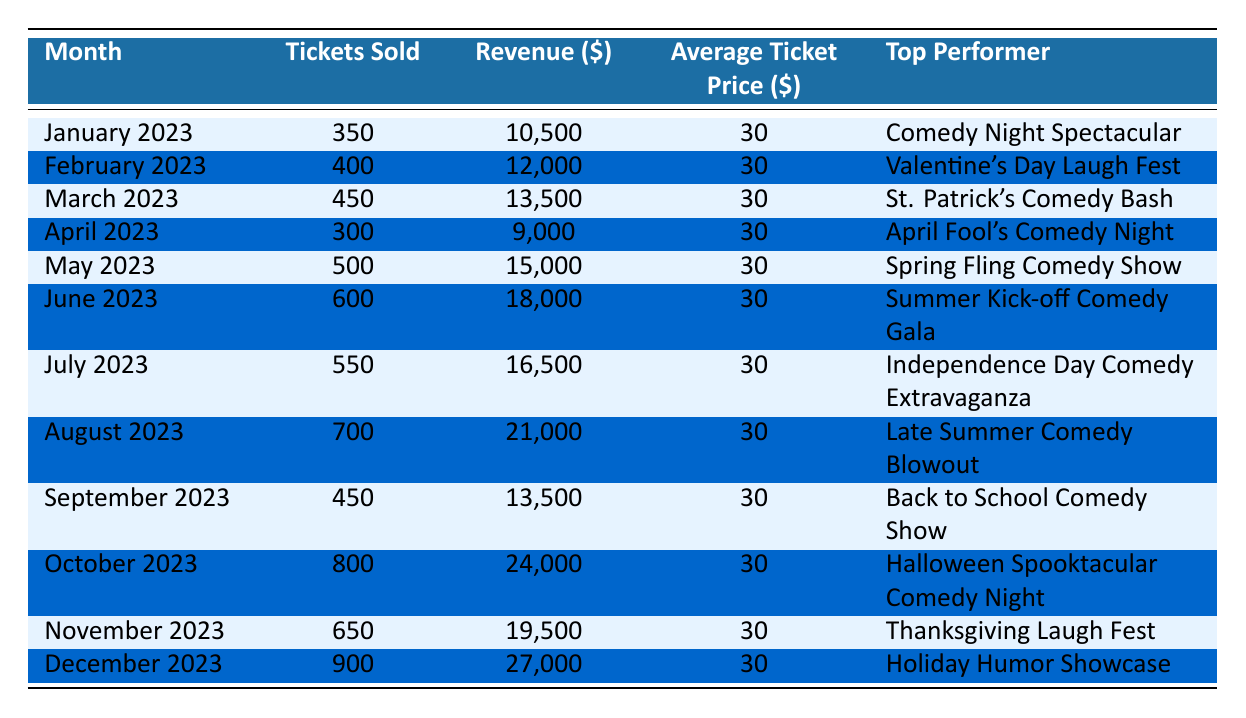What was the total revenue for the comedy club in August 2023? Looking at the table, the revenue listed for August 2023 is 21,000 dollars. This is a direct retrieval of information from the respective row.
Answer: 21,000 Which month had the highest ticket sales, and how many tickets were sold? By reviewing the table, October 2023 shows the highest ticket sales with 800 tickets sold. This can be found by comparing the "Tickets Sold" column across all months.
Answer: October 2023, 800 What is the average number of tickets sold per month for the year 2023? To find the average, we first total all the tickets sold across the months: 350 + 400 + 450 + 300 + 500 + 600 + 550 + 700 + 450 + 800 + 650 + 900 = 6,300 total tickets. There are 12 months, so the average is 6,300 / 12 = 525 tickets per month.
Answer: 525 Did the comedy club sell more tickets in December 2023 than in June 2023? Comparing the two months, December 2023 had 900 tickets sold, while June 2023 had 600 tickets sold. Since 900 is greater than 600, the answer is yes.
Answer: Yes Which top performer had the lowest revenue in 2023, and what was that revenue? By inspecting the revenue figures in the table, April 2023 had the lowest revenue at 9,000 dollars for "April Fool's Comedy Night." This compares all top performers to determine which has the lowest revenue identified in their respective rows.
Answer: April Fool's Comedy Night, 9,000 How much additional revenue was generated in October 2023 compared to January 2023? October 2023 generated 24,000 dollars, while January 2023 generated 10,500 dollars. Subtracting the two gives: 24,000 - 10,500 = 13,500 dollars additional revenue in October compared to January.
Answer: 13,500 Was the average ticket price consistent throughout the year, and if so, what was that price? Yes, the average ticket price remained at 30 dollars for each month as noted in the "Average Ticket Price" column. Since there are no variations across the rows, we can confirm the consistency.
Answer: Yes, 30 In total, how many tickets were sold from May to August 2023? Adding the tickets sold for these months gives us: May (500) + June (600) + July (550) + August (700) = 2,350 total tickets sold from May to August 2023.
Answer: 2,350 What date marks the highest top performer of the year regarding ticket sales, and what is its name? October 2023 has the highest ticket sales with the top performer being "Halloween Spooktacular Comedy Night," as identified in the respective row for that month.
Answer: October 2023, Halloween Spooktacular Comedy Night 